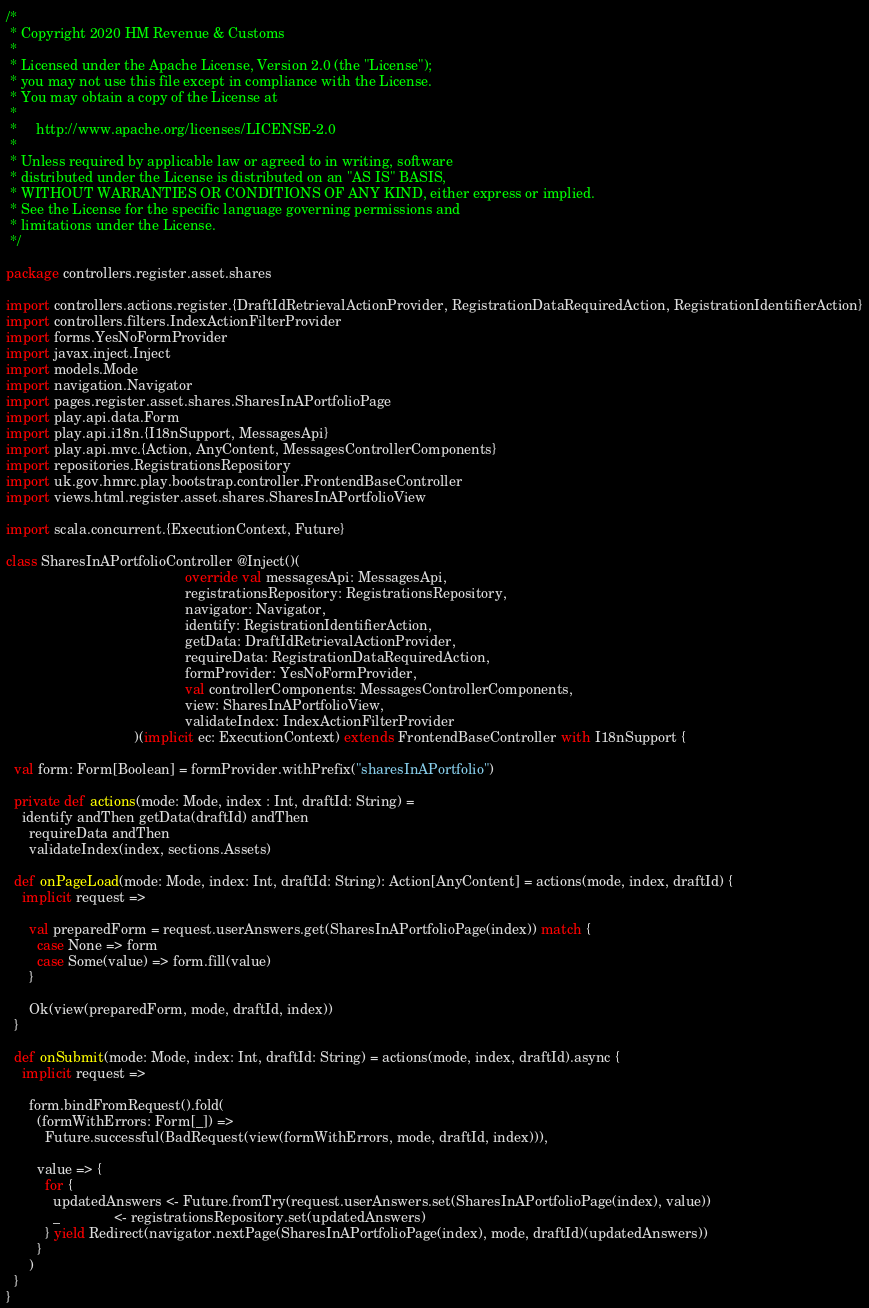Convert code to text. <code><loc_0><loc_0><loc_500><loc_500><_Scala_>/*
 * Copyright 2020 HM Revenue & Customs
 *
 * Licensed under the Apache License, Version 2.0 (the "License");
 * you may not use this file except in compliance with the License.
 * You may obtain a copy of the License at
 *
 *     http://www.apache.org/licenses/LICENSE-2.0
 *
 * Unless required by applicable law or agreed to in writing, software
 * distributed under the License is distributed on an "AS IS" BASIS,
 * WITHOUT WARRANTIES OR CONDITIONS OF ANY KIND, either express or implied.
 * See the License for the specific language governing permissions and
 * limitations under the License.
 */

package controllers.register.asset.shares

import controllers.actions.register.{DraftIdRetrievalActionProvider, RegistrationDataRequiredAction, RegistrationIdentifierAction}
import controllers.filters.IndexActionFilterProvider
import forms.YesNoFormProvider
import javax.inject.Inject
import models.Mode
import navigation.Navigator
import pages.register.asset.shares.SharesInAPortfolioPage
import play.api.data.Form
import play.api.i18n.{I18nSupport, MessagesApi}
import play.api.mvc.{Action, AnyContent, MessagesControllerComponents}
import repositories.RegistrationsRepository
import uk.gov.hmrc.play.bootstrap.controller.FrontendBaseController
import views.html.register.asset.shares.SharesInAPortfolioView

import scala.concurrent.{ExecutionContext, Future}

class SharesInAPortfolioController @Inject()(
                                              override val messagesApi: MessagesApi,
                                              registrationsRepository: RegistrationsRepository,
                                              navigator: Navigator,
                                              identify: RegistrationIdentifierAction,
                                              getData: DraftIdRetrievalActionProvider,
                                              requireData: RegistrationDataRequiredAction,
                                              formProvider: YesNoFormProvider,
                                              val controllerComponents: MessagesControllerComponents,
                                              view: SharesInAPortfolioView,
                                              validateIndex: IndexActionFilterProvider
                                 )(implicit ec: ExecutionContext) extends FrontendBaseController with I18nSupport {

  val form: Form[Boolean] = formProvider.withPrefix("sharesInAPortfolio")

  private def actions(mode: Mode, index : Int, draftId: String) =
    identify andThen getData(draftId) andThen
      requireData andThen
      validateIndex(index, sections.Assets)

  def onPageLoad(mode: Mode, index: Int, draftId: String): Action[AnyContent] = actions(mode, index, draftId) {
    implicit request =>

      val preparedForm = request.userAnswers.get(SharesInAPortfolioPage(index)) match {
        case None => form
        case Some(value) => form.fill(value)
      }

      Ok(view(preparedForm, mode, draftId, index))
  }

  def onSubmit(mode: Mode, index: Int, draftId: String) = actions(mode, index, draftId).async {
    implicit request =>

      form.bindFromRequest().fold(
        (formWithErrors: Form[_]) =>
          Future.successful(BadRequest(view(formWithErrors, mode, draftId, index))),

        value => {
          for {
            updatedAnswers <- Future.fromTry(request.userAnswers.set(SharesInAPortfolioPage(index), value))
            _              <- registrationsRepository.set(updatedAnswers)
          } yield Redirect(navigator.nextPage(SharesInAPortfolioPage(index), mode, draftId)(updatedAnswers))
        }
      )
  }
}
</code> 